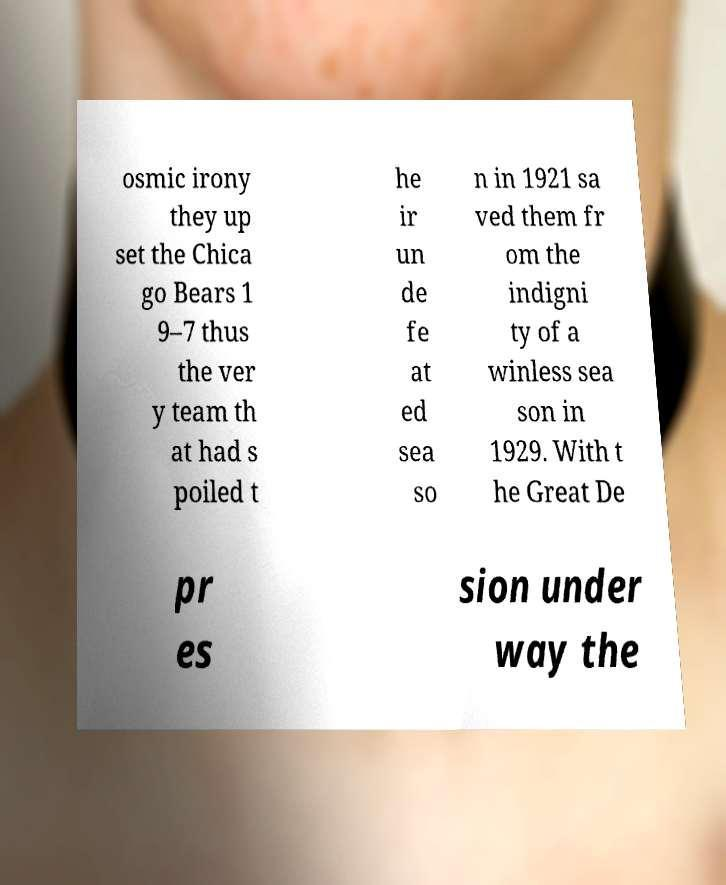Could you assist in decoding the text presented in this image and type it out clearly? osmic irony they up set the Chica go Bears 1 9–7 thus the ver y team th at had s poiled t he ir un de fe at ed sea so n in 1921 sa ved them fr om the indigni ty of a winless sea son in 1929. With t he Great De pr es sion under way the 